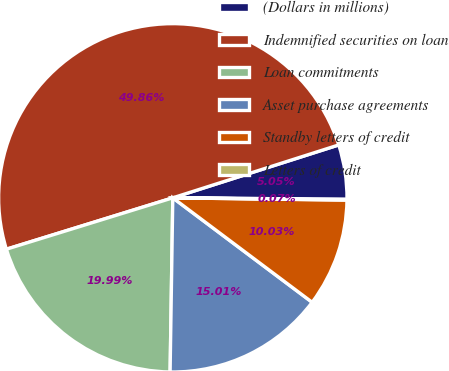Convert chart to OTSL. <chart><loc_0><loc_0><loc_500><loc_500><pie_chart><fcel>(Dollars in millions)<fcel>Indemnified securities on loan<fcel>Loan commitments<fcel>Asset purchase agreements<fcel>Standby letters of credit<fcel>Letters of credit<nl><fcel>5.05%<fcel>49.86%<fcel>19.99%<fcel>15.01%<fcel>10.03%<fcel>0.07%<nl></chart> 